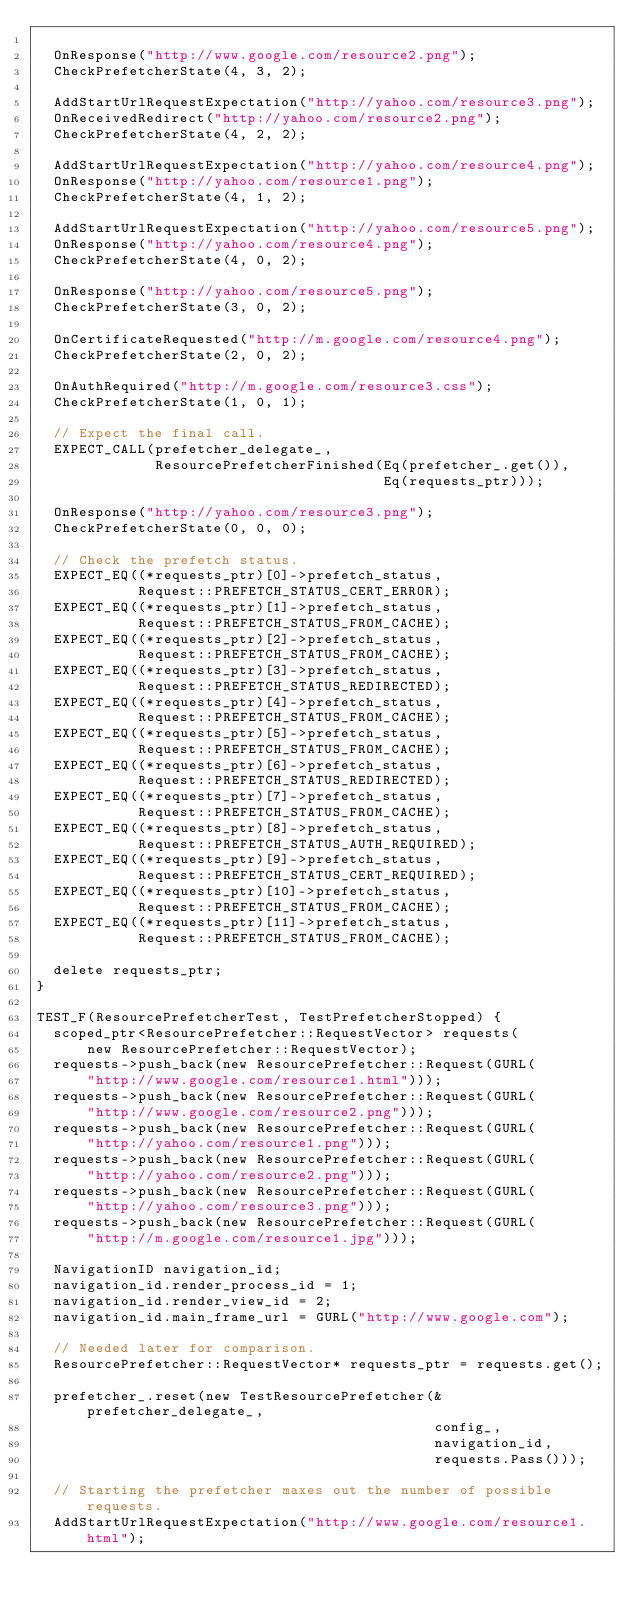<code> <loc_0><loc_0><loc_500><loc_500><_C++_>
  OnResponse("http://www.google.com/resource2.png");
  CheckPrefetcherState(4, 3, 2);

  AddStartUrlRequestExpectation("http://yahoo.com/resource3.png");
  OnReceivedRedirect("http://yahoo.com/resource2.png");
  CheckPrefetcherState(4, 2, 2);

  AddStartUrlRequestExpectation("http://yahoo.com/resource4.png");
  OnResponse("http://yahoo.com/resource1.png");
  CheckPrefetcherState(4, 1, 2);

  AddStartUrlRequestExpectation("http://yahoo.com/resource5.png");
  OnResponse("http://yahoo.com/resource4.png");
  CheckPrefetcherState(4, 0, 2);

  OnResponse("http://yahoo.com/resource5.png");
  CheckPrefetcherState(3, 0, 2);

  OnCertificateRequested("http://m.google.com/resource4.png");
  CheckPrefetcherState(2, 0, 2);

  OnAuthRequired("http://m.google.com/resource3.css");
  CheckPrefetcherState(1, 0, 1);

  // Expect the final call.
  EXPECT_CALL(prefetcher_delegate_,
              ResourcePrefetcherFinished(Eq(prefetcher_.get()),
                                         Eq(requests_ptr)));

  OnResponse("http://yahoo.com/resource3.png");
  CheckPrefetcherState(0, 0, 0);

  // Check the prefetch status.
  EXPECT_EQ((*requests_ptr)[0]->prefetch_status,
            Request::PREFETCH_STATUS_CERT_ERROR);
  EXPECT_EQ((*requests_ptr)[1]->prefetch_status,
            Request::PREFETCH_STATUS_FROM_CACHE);
  EXPECT_EQ((*requests_ptr)[2]->prefetch_status,
            Request::PREFETCH_STATUS_FROM_CACHE);
  EXPECT_EQ((*requests_ptr)[3]->prefetch_status,
            Request::PREFETCH_STATUS_REDIRECTED);
  EXPECT_EQ((*requests_ptr)[4]->prefetch_status,
            Request::PREFETCH_STATUS_FROM_CACHE);
  EXPECT_EQ((*requests_ptr)[5]->prefetch_status,
            Request::PREFETCH_STATUS_FROM_CACHE);
  EXPECT_EQ((*requests_ptr)[6]->prefetch_status,
            Request::PREFETCH_STATUS_REDIRECTED);
  EXPECT_EQ((*requests_ptr)[7]->prefetch_status,
            Request::PREFETCH_STATUS_FROM_CACHE);
  EXPECT_EQ((*requests_ptr)[8]->prefetch_status,
            Request::PREFETCH_STATUS_AUTH_REQUIRED);
  EXPECT_EQ((*requests_ptr)[9]->prefetch_status,
            Request::PREFETCH_STATUS_CERT_REQUIRED);
  EXPECT_EQ((*requests_ptr)[10]->prefetch_status,
            Request::PREFETCH_STATUS_FROM_CACHE);
  EXPECT_EQ((*requests_ptr)[11]->prefetch_status,
            Request::PREFETCH_STATUS_FROM_CACHE);

  delete requests_ptr;
}

TEST_F(ResourcePrefetcherTest, TestPrefetcherStopped) {
  scoped_ptr<ResourcePrefetcher::RequestVector> requests(
      new ResourcePrefetcher::RequestVector);
  requests->push_back(new ResourcePrefetcher::Request(GURL(
      "http://www.google.com/resource1.html")));
  requests->push_back(new ResourcePrefetcher::Request(GURL(
      "http://www.google.com/resource2.png")));
  requests->push_back(new ResourcePrefetcher::Request(GURL(
      "http://yahoo.com/resource1.png")));
  requests->push_back(new ResourcePrefetcher::Request(GURL(
      "http://yahoo.com/resource2.png")));
  requests->push_back(new ResourcePrefetcher::Request(GURL(
      "http://yahoo.com/resource3.png")));
  requests->push_back(new ResourcePrefetcher::Request(GURL(
      "http://m.google.com/resource1.jpg")));

  NavigationID navigation_id;
  navigation_id.render_process_id = 1;
  navigation_id.render_view_id = 2;
  navigation_id.main_frame_url = GURL("http://www.google.com");

  // Needed later for comparison.
  ResourcePrefetcher::RequestVector* requests_ptr = requests.get();

  prefetcher_.reset(new TestResourcePrefetcher(&prefetcher_delegate_,
                                               config_,
                                               navigation_id,
                                               requests.Pass()));

  // Starting the prefetcher maxes out the number of possible requests.
  AddStartUrlRequestExpectation("http://www.google.com/resource1.html");</code> 